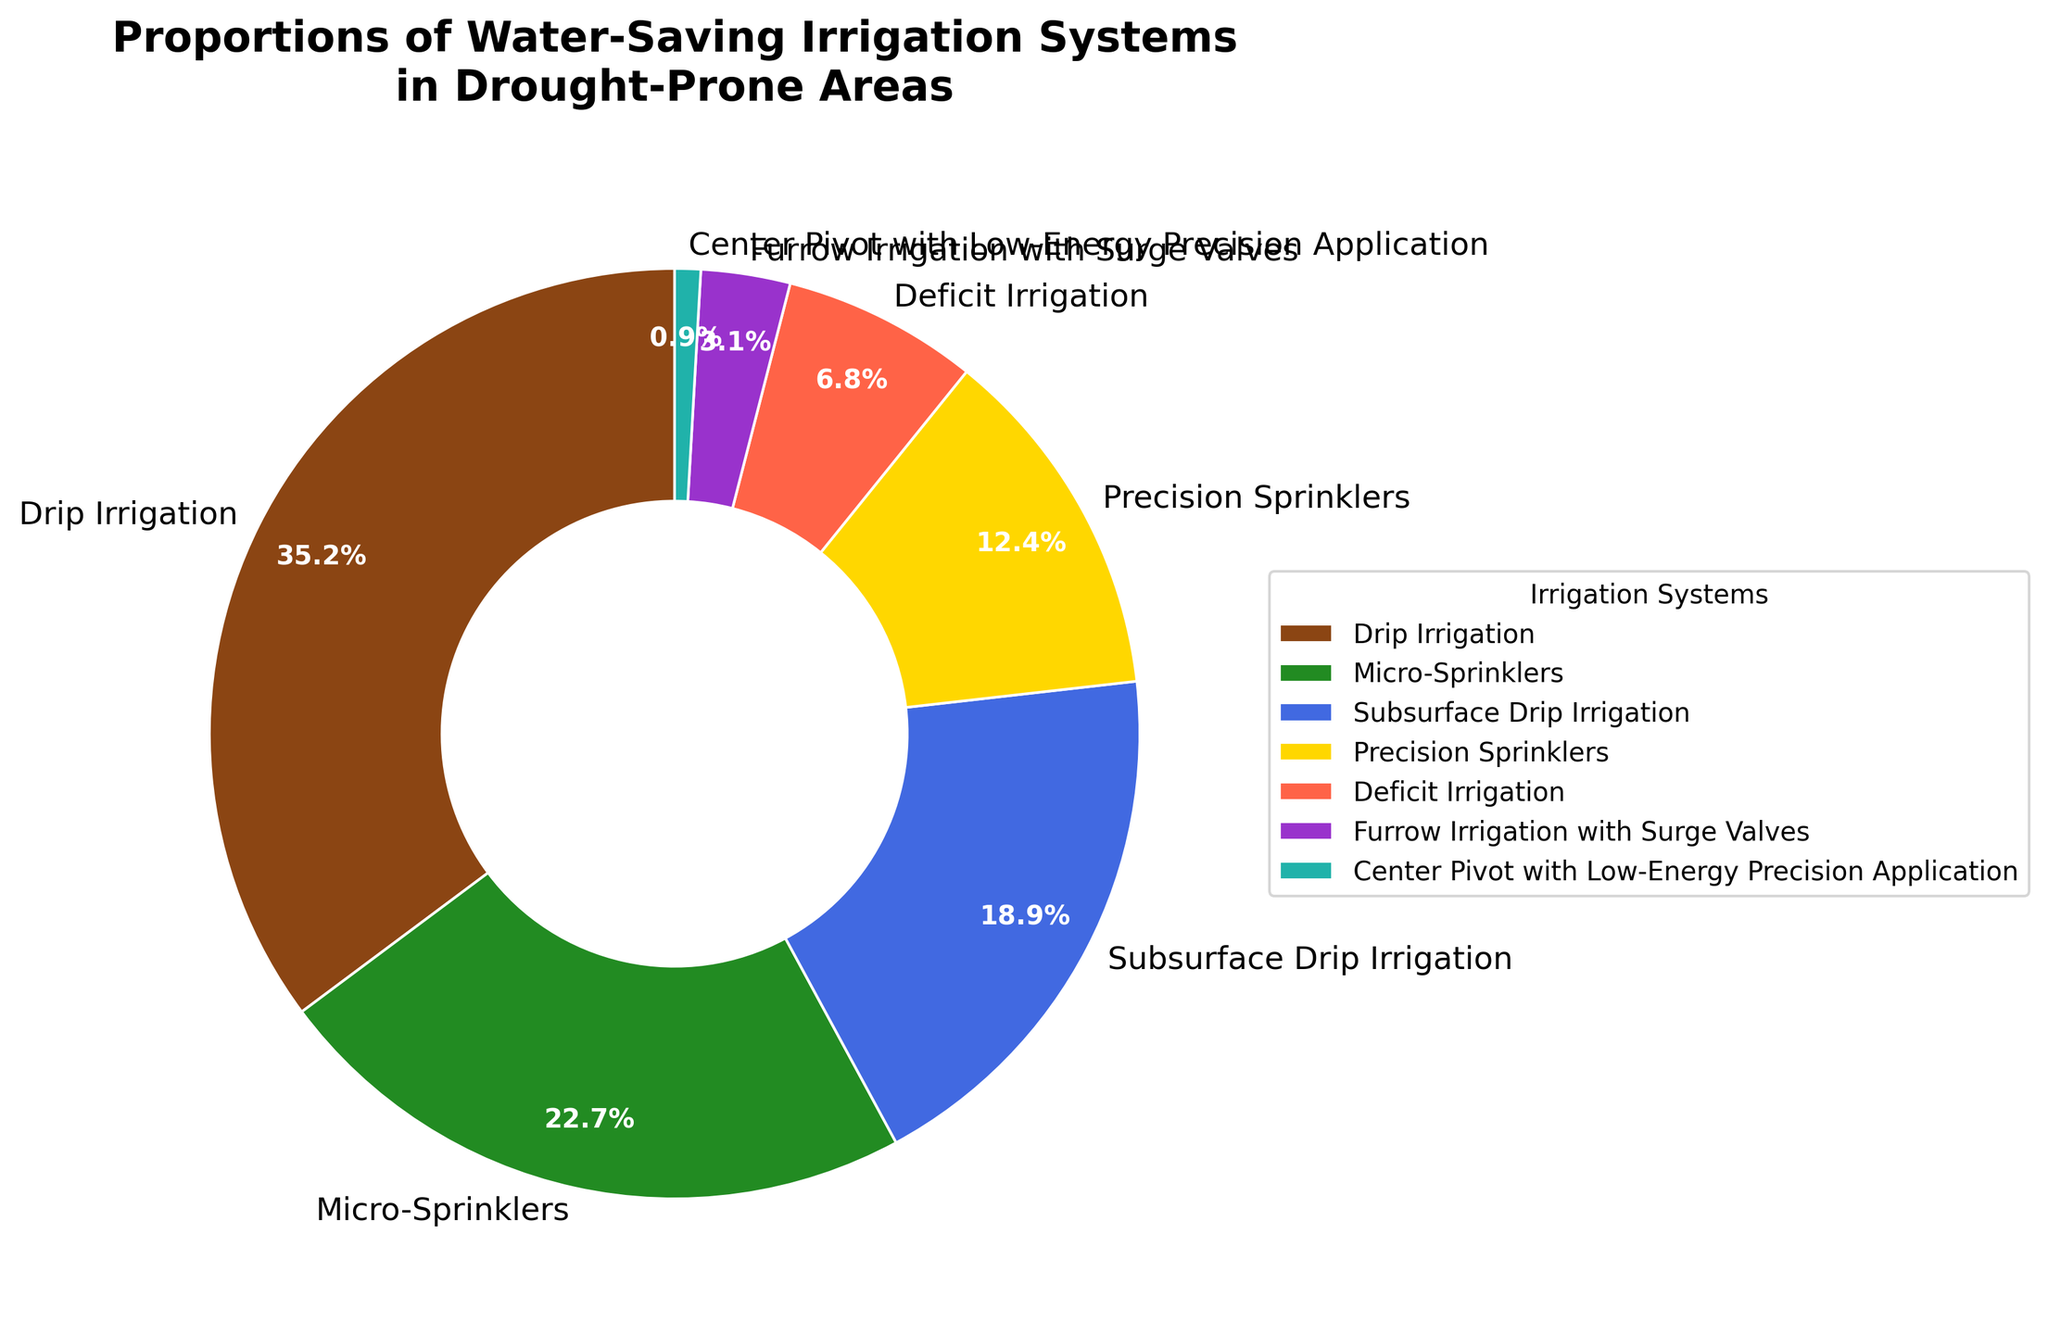What is the largest proportion of water-saving irrigation systems in drought-prone areas? By inspecting the pie chart, the largest section belongs to Drip Irrigation with 35.2%.
Answer: 35.2% Which irrigation system has the smallest proportion? The pie chart shows that Center Pivot with Low-Energy Precision Application has the smallest section with only 0.9%.
Answer: Center Pivot with Low-Energy Precision Application What is the combined proportion of Drip Irrigation and Micro-Sprinklers? Drip Irrigation is 35.2% and Micro-Sprinklers is 22.7%. Adding these together, 35.2 + 22.7 = 57.9%.
Answer: 57.9% Which irrigation systems have a proportion greater than 20%? In the pie chart, Drip Irrigation (35.2%) and Micro-Sprinklers (22.7%) are the only systems with more than 20%.
Answer: Drip Irrigation, Micro-Sprinklers What is the total proportion of Subsurface Drip Irrigation, Precision Sprinklers, and Deficit Irrigation combined? The pie chart lists Subsurface Drip Irrigation at 18.9%, Precision Sprinklers at 12.4%, and Deficit Irrigation at 6.8%. Adding these, 18.9 + 12.4 + 6.8 = 38.1%.
Answer: 38.1% How much larger is the proportion of Drip Irrigation compared to Furrow Irrigation with Surge Valves? Drip Irrigation is 35.2% and Furrow Irrigation with Surge Valves is 3.1%. Subtracting these, 35.2 - 3.1 = 32.1%.
Answer: 32.1% Which irrigation system is represented by the green section in the pie chart? The pie chart indicates green corresponds to Micro-Sprinklers, which has a 22.7% proportion.
Answer: Micro-Sprinklers Is the proportion of Deficit Irrigation greater or smaller than 10%? The pie chart shows Deficit Irrigation at 6.8%, which is smaller than 10%.
Answer: Smaller What is the second largest proportion of water-saving irrigation systems? After Drip Irrigation (35.2%), the second largest proportion is Micro-Sprinklers at 22.7%.
Answer: Micro-Sprinklers How much smaller is the proportion of Center Pivot with Low-Energy Precision Application compared to Precision Sprinklers? The pie chart shows Center Pivot with Low-Energy Precision Application at 0.9% and Precision Sprinklers at 12.4%. Subtracting these, 12.4 - 0.9 = 11.5%.
Answer: 11.5% 